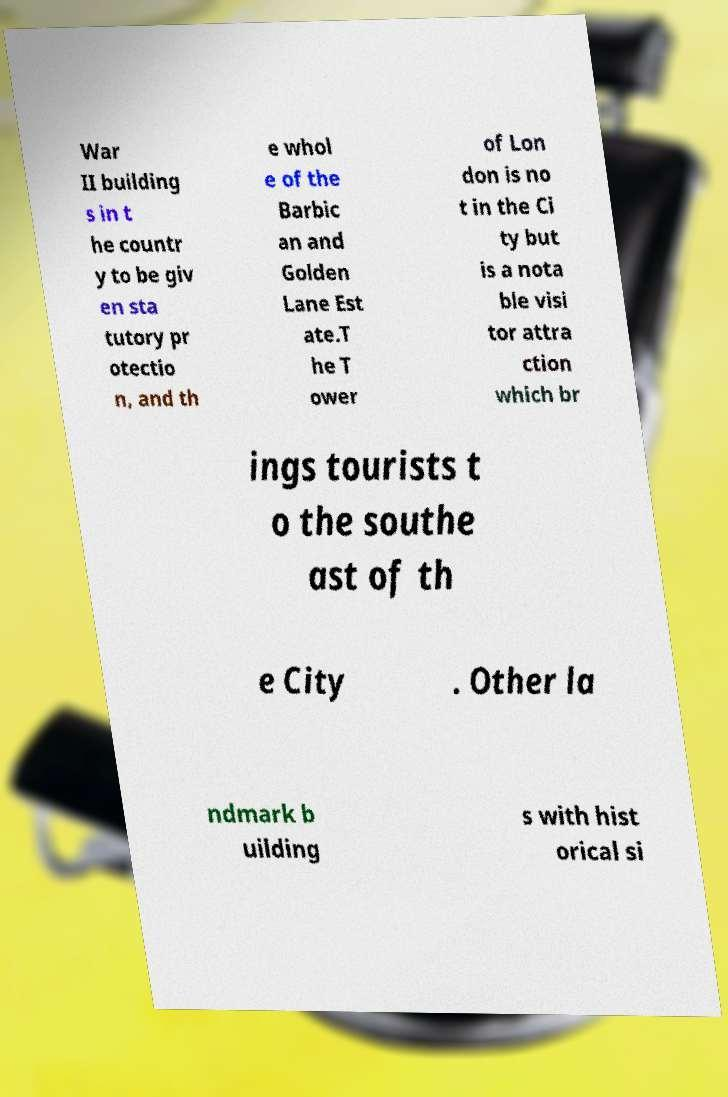What messages or text are displayed in this image? I need them in a readable, typed format. War II building s in t he countr y to be giv en sta tutory pr otectio n, and th e whol e of the Barbic an and Golden Lane Est ate.T he T ower of Lon don is no t in the Ci ty but is a nota ble visi tor attra ction which br ings tourists t o the southe ast of th e City . Other la ndmark b uilding s with hist orical si 